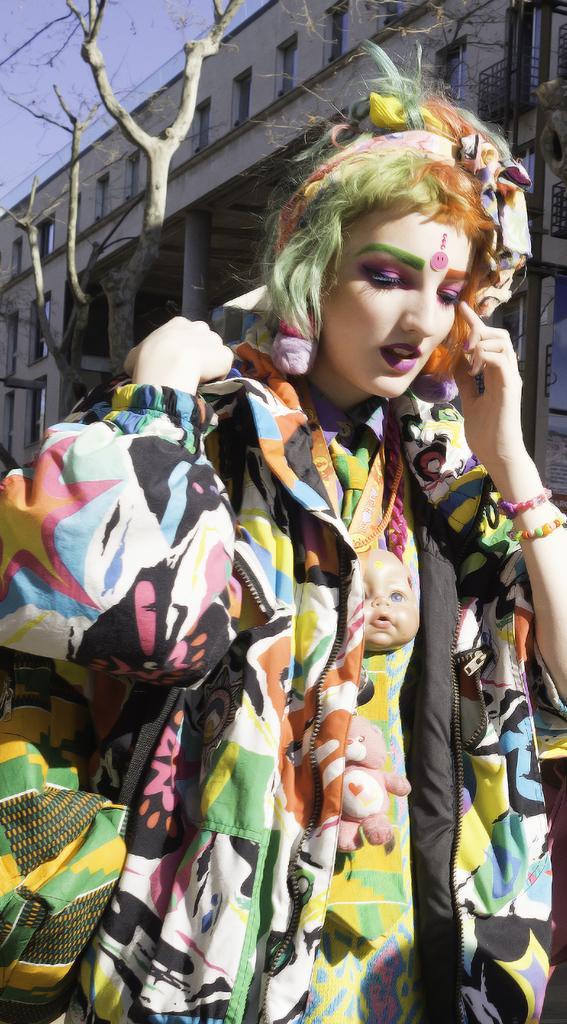Can you describe this image briefly? In this image we can see a woman. She is wearing colorful jacket. Behind her dry tree and building is there. 